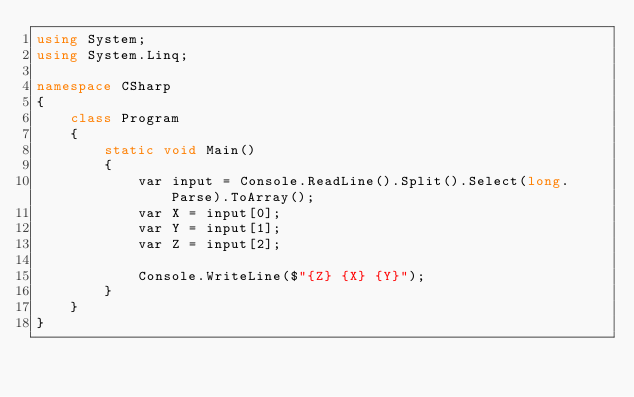Convert code to text. <code><loc_0><loc_0><loc_500><loc_500><_C#_>using System;
using System.Linq;

namespace CSharp
{
    class Program
    {
        static void Main()
        {
            var input = Console.ReadLine().Split().Select(long.Parse).ToArray();
            var X = input[0];
            var Y = input[1];
            var Z = input[2];

            Console.WriteLine($"{Z} {X} {Y}");
        }
    }
}
</code> 